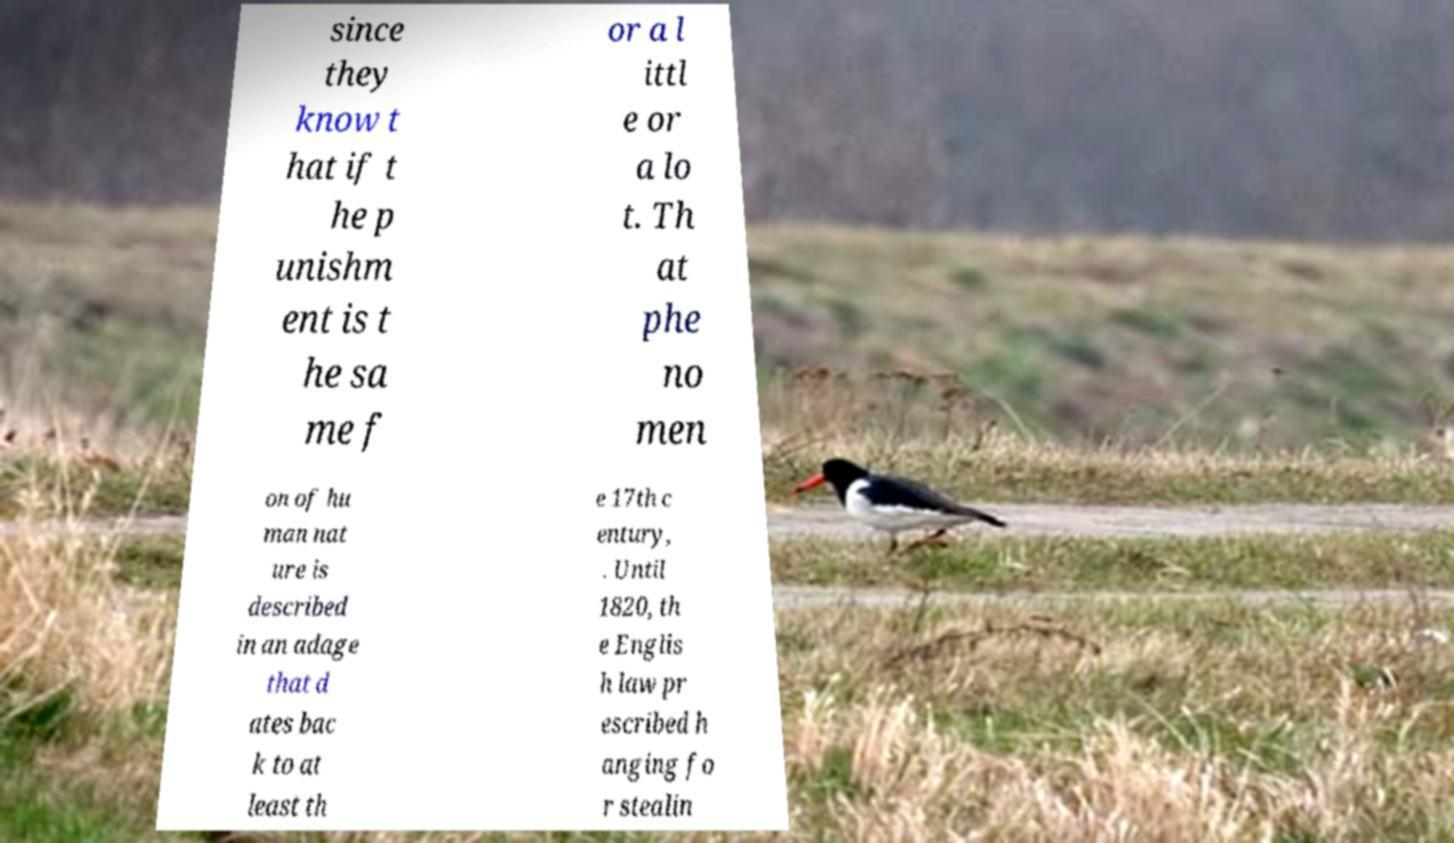Could you extract and type out the text from this image? since they know t hat if t he p unishm ent is t he sa me f or a l ittl e or a lo t. Th at phe no men on of hu man nat ure is described in an adage that d ates bac k to at least th e 17th c entury, . Until 1820, th e Englis h law pr escribed h anging fo r stealin 